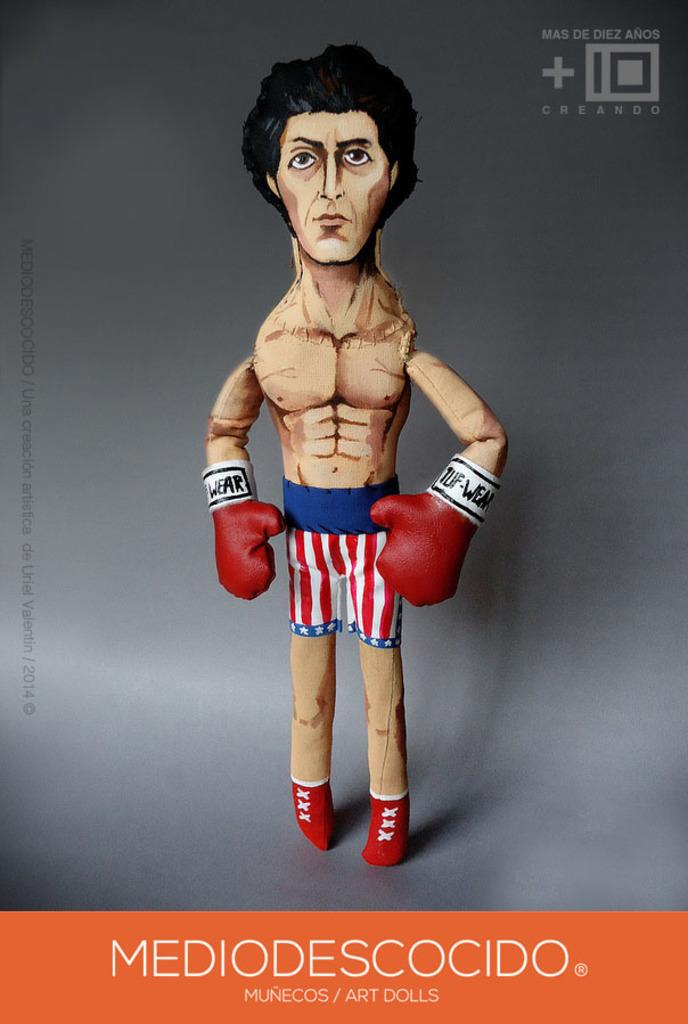<image>
Share a concise interpretation of the image provided. a Mediodescocido doll that has some boxing gloves on 